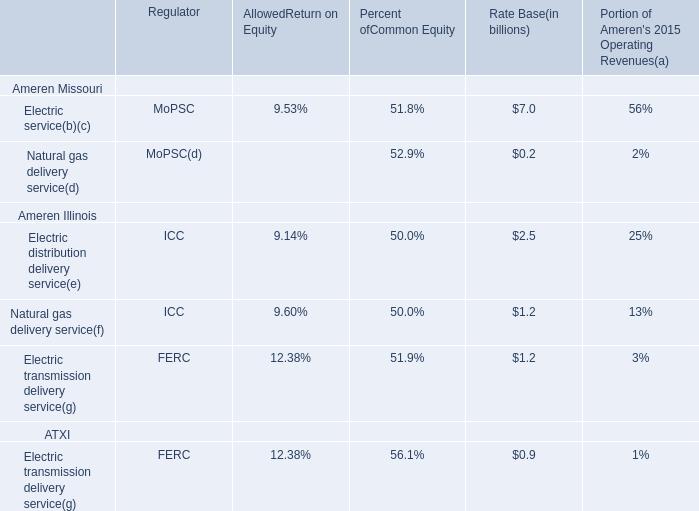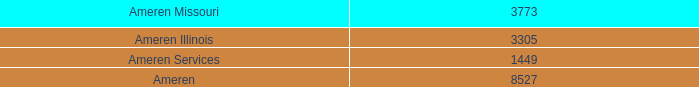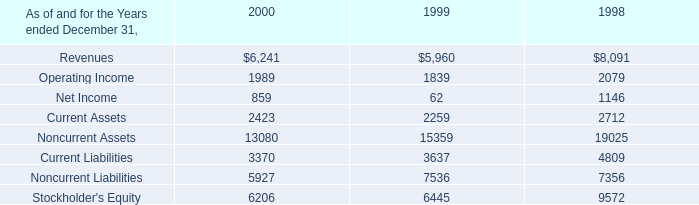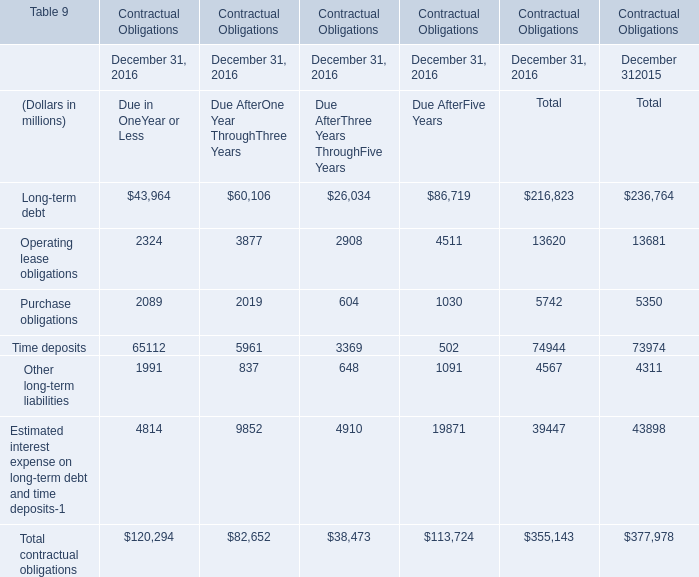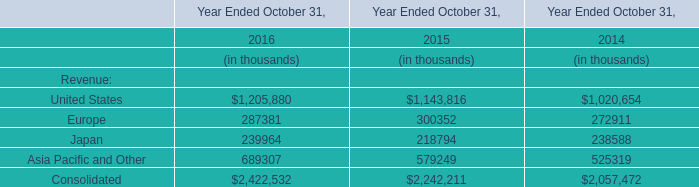What's the sum of the Long-term debt and Operating lease obligations in the years where Long-term debt is positive? (in millions) 
Computations: (236764 + 13681)
Answer: 250445.0. 